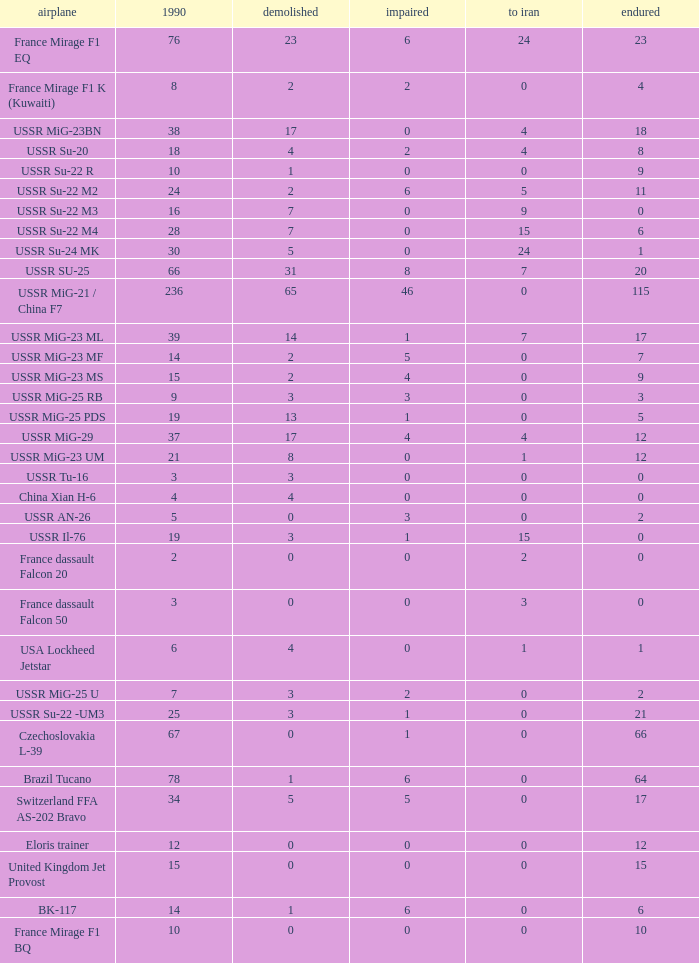If 4 traveled to iran and the quantity that endured was under 1 1.0. 